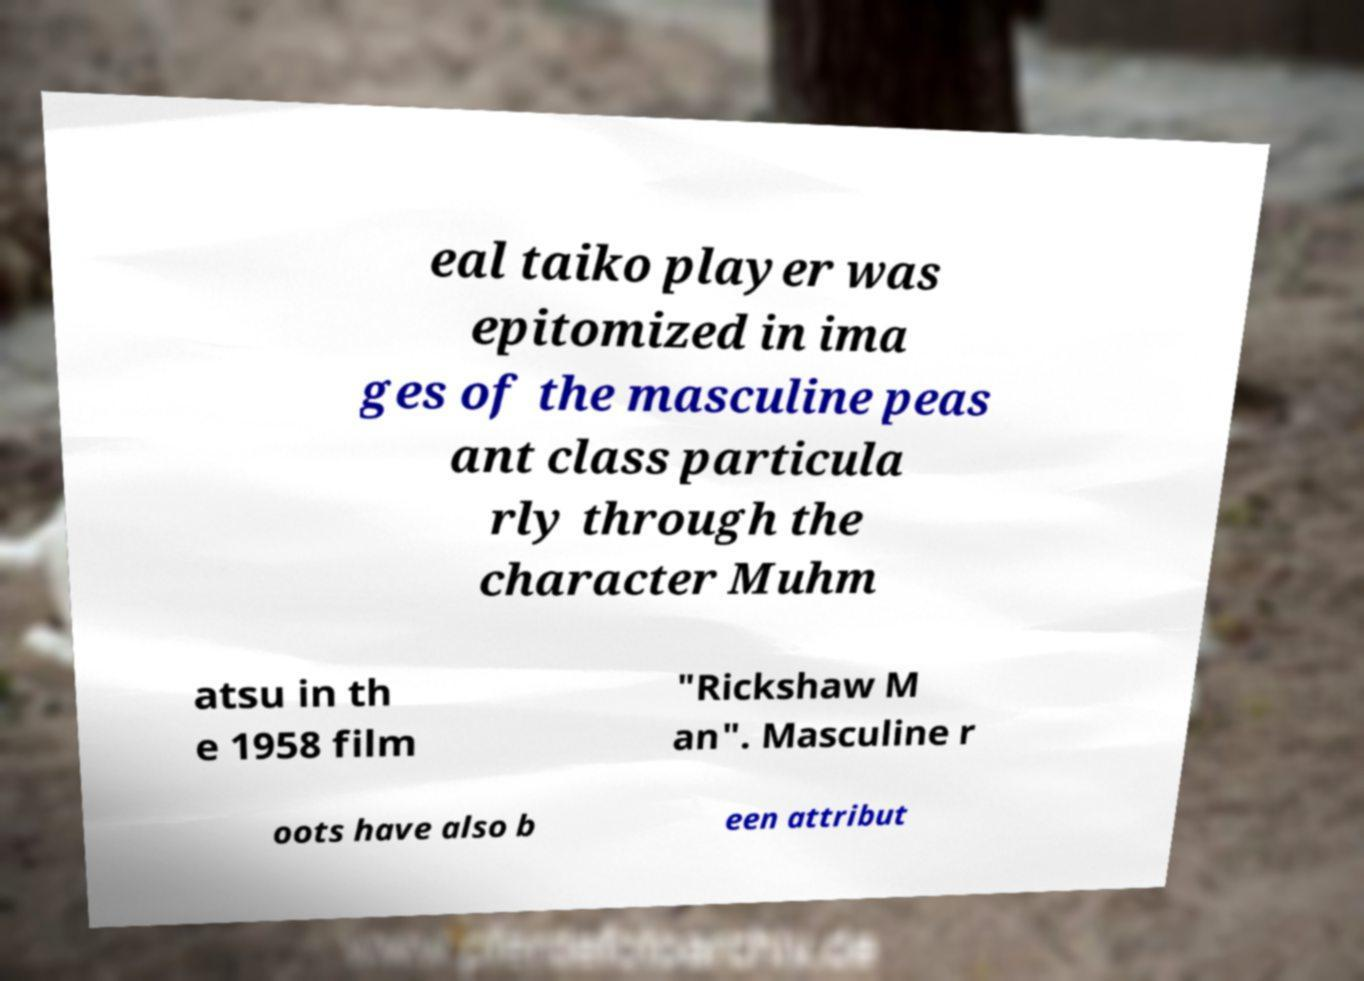I need the written content from this picture converted into text. Can you do that? eal taiko player was epitomized in ima ges of the masculine peas ant class particula rly through the character Muhm atsu in th e 1958 film "Rickshaw M an". Masculine r oots have also b een attribut 